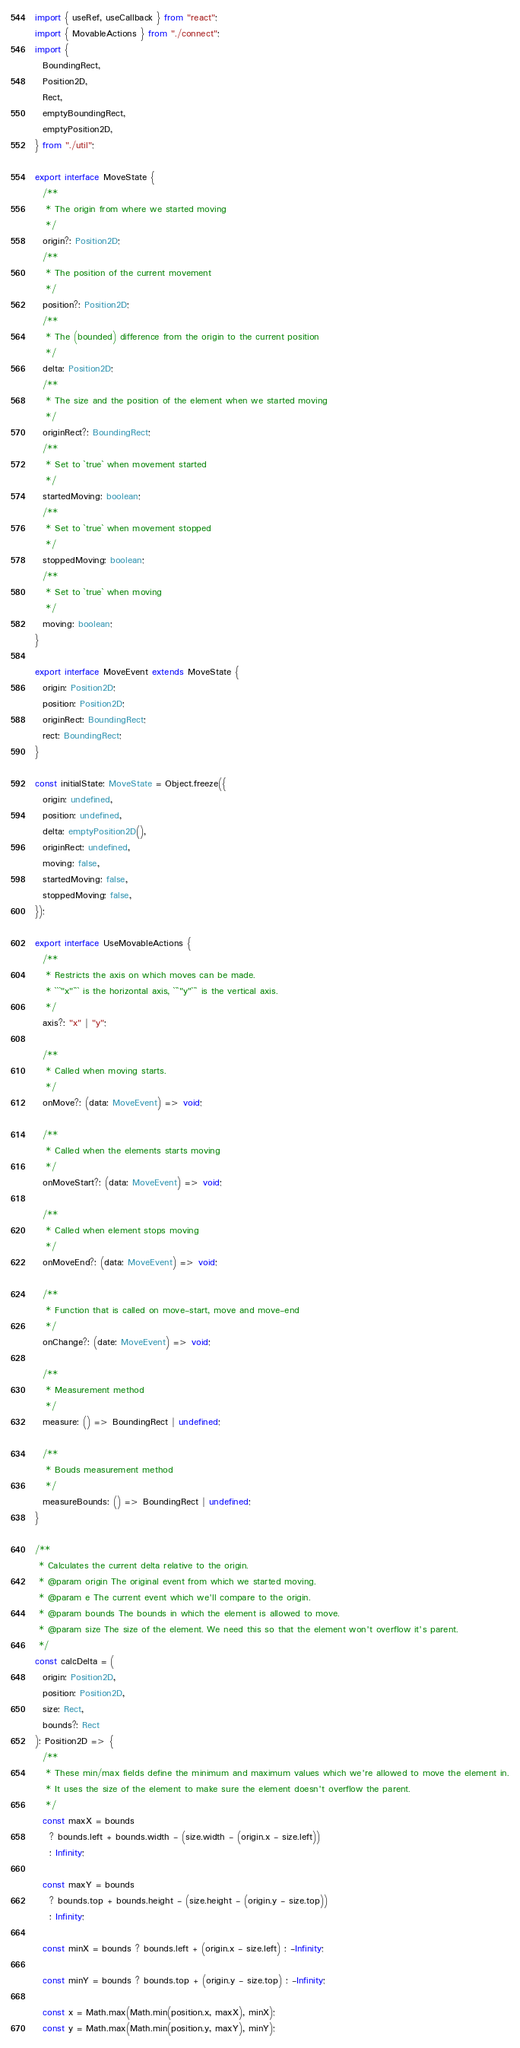<code> <loc_0><loc_0><loc_500><loc_500><_TypeScript_>import { useRef, useCallback } from "react";
import { MovableActions } from "./connect";
import {
  BoundingRect,
  Position2D,
  Rect,
  emptyBoundingRect,
  emptyPosition2D,
} from "./util";

export interface MoveState {
  /**
   * The origin from where we started moving
   */
  origin?: Position2D;
  /**
   * The position of the current movement
   */
  position?: Position2D;
  /**
   * The (bounded) difference from the origin to the current position
   */
  delta: Position2D;
  /**
   * The size and the position of the element when we started moving
   */
  originRect?: BoundingRect;
  /**
   * Set to `true` when movement started
   */
  startedMoving: boolean;
  /**
   * Set to `true` when movement stopped
   */
  stoppedMoving: boolean;
  /**
   * Set to `true` when moving
   */
  moving: boolean;
}

export interface MoveEvent extends MoveState {
  origin: Position2D;
  position: Position2D;
  originRect: BoundingRect;
  rect: BoundingRect;
}

const initialState: MoveState = Object.freeze({
  origin: undefined,
  position: undefined,
  delta: emptyPosition2D(),
  originRect: undefined,
  moving: false,
  startedMoving: false,
  stoppedMoving: false,
});

export interface UseMovableActions {
  /**
   * Restricts the axis on which moves can be made.
   * ```"x"``` is the horizontal axis, ```"y"``` is the vertical axis.
   */
  axis?: "x" | "y";

  /**
   * Called when moving starts.
   */
  onMove?: (data: MoveEvent) => void;

  /**
   * Called when the elements starts moving
   */
  onMoveStart?: (data: MoveEvent) => void;

  /**
   * Called when element stops moving
   */
  onMoveEnd?: (data: MoveEvent) => void;

  /**
   * Function that is called on move-start, move and move-end
   */
  onChange?: (date: MoveEvent) => void;

  /**
   * Measurement method
   */
  measure: () => BoundingRect | undefined;

  /**
   * Bouds measurement method
   */
  measureBounds: () => BoundingRect | undefined;
}

/**
 * Calculates the current delta relative to the origin.
 * @param origin The original event from which we started moving.
 * @param e The current event which we'll compare to the origin.
 * @param bounds The bounds in which the element is allowed to move.
 * @param size The size of the element. We need this so that the element won't overflow it's parent.
 */
const calcDelta = (
  origin: Position2D,
  position: Position2D,
  size: Rect,
  bounds?: Rect
): Position2D => {
  /**
   * These min/max fields define the minimum and maximum values which we're allowed to move the element in.
   * It uses the size of the element to make sure the element doesn't overflow the parent.
   */
  const maxX = bounds
    ? bounds.left + bounds.width - (size.width - (origin.x - size.left))
    : Infinity;

  const maxY = bounds
    ? bounds.top + bounds.height - (size.height - (origin.y - size.top))
    : Infinity;

  const minX = bounds ? bounds.left + (origin.x - size.left) : -Infinity;

  const minY = bounds ? bounds.top + (origin.y - size.top) : -Infinity;

  const x = Math.max(Math.min(position.x, maxX), minX);
  const y = Math.max(Math.min(position.y, maxY), minY);
</code> 